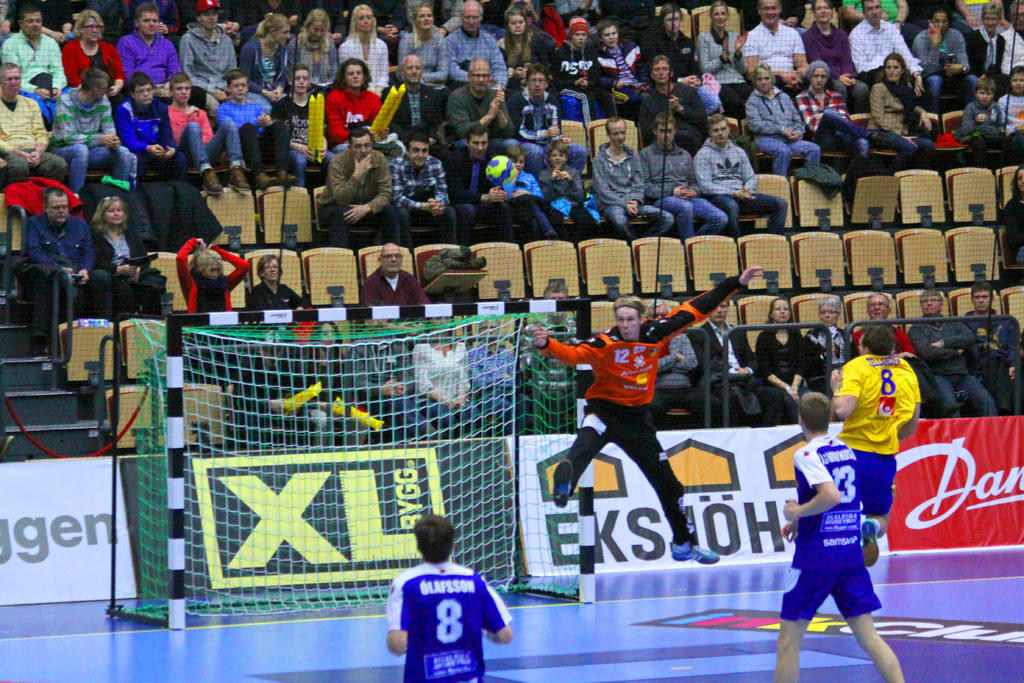What sport is being played in this image? The sport being played is handball, a team sport where players aim to throw the ball into the opponent's goal. 